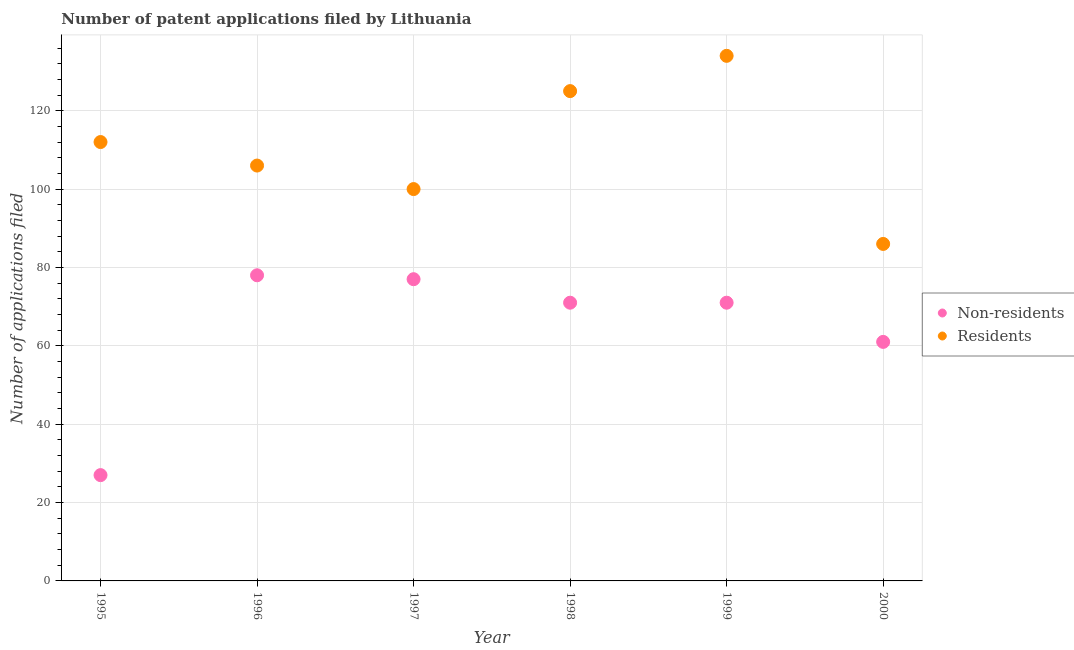How many different coloured dotlines are there?
Provide a succinct answer. 2. Is the number of dotlines equal to the number of legend labels?
Provide a succinct answer. Yes. What is the number of patent applications by residents in 1998?
Keep it short and to the point. 125. Across all years, what is the maximum number of patent applications by residents?
Your answer should be very brief. 134. Across all years, what is the minimum number of patent applications by non residents?
Your answer should be very brief. 27. In which year was the number of patent applications by residents maximum?
Give a very brief answer. 1999. In which year was the number of patent applications by non residents minimum?
Make the answer very short. 1995. What is the total number of patent applications by non residents in the graph?
Make the answer very short. 385. What is the difference between the number of patent applications by non residents in 1999 and that in 2000?
Your response must be concise. 10. What is the difference between the number of patent applications by residents in 2000 and the number of patent applications by non residents in 1998?
Your answer should be compact. 15. What is the average number of patent applications by residents per year?
Provide a short and direct response. 110.5. In the year 1998, what is the difference between the number of patent applications by residents and number of patent applications by non residents?
Ensure brevity in your answer.  54. Is the difference between the number of patent applications by residents in 1996 and 1998 greater than the difference between the number of patent applications by non residents in 1996 and 1998?
Give a very brief answer. No. What is the difference between the highest and the second highest number of patent applications by non residents?
Provide a short and direct response. 1. What is the difference between the highest and the lowest number of patent applications by residents?
Provide a succinct answer. 48. Does the number of patent applications by residents monotonically increase over the years?
Provide a short and direct response. No. Is the number of patent applications by non residents strictly greater than the number of patent applications by residents over the years?
Your answer should be very brief. No. Are the values on the major ticks of Y-axis written in scientific E-notation?
Your response must be concise. No. Where does the legend appear in the graph?
Your response must be concise. Center right. How many legend labels are there?
Ensure brevity in your answer.  2. How are the legend labels stacked?
Offer a terse response. Vertical. What is the title of the graph?
Keep it short and to the point. Number of patent applications filed by Lithuania. What is the label or title of the Y-axis?
Keep it short and to the point. Number of applications filed. What is the Number of applications filed of Residents in 1995?
Your response must be concise. 112. What is the Number of applications filed in Non-residents in 1996?
Ensure brevity in your answer.  78. What is the Number of applications filed in Residents in 1996?
Your answer should be compact. 106. What is the Number of applications filed in Non-residents in 1997?
Make the answer very short. 77. What is the Number of applications filed of Residents in 1998?
Your answer should be very brief. 125. What is the Number of applications filed in Residents in 1999?
Offer a terse response. 134. What is the Number of applications filed in Non-residents in 2000?
Your response must be concise. 61. Across all years, what is the maximum Number of applications filed of Non-residents?
Offer a very short reply. 78. Across all years, what is the maximum Number of applications filed in Residents?
Your response must be concise. 134. What is the total Number of applications filed in Non-residents in the graph?
Your answer should be compact. 385. What is the total Number of applications filed of Residents in the graph?
Provide a short and direct response. 663. What is the difference between the Number of applications filed in Non-residents in 1995 and that in 1996?
Ensure brevity in your answer.  -51. What is the difference between the Number of applications filed in Residents in 1995 and that in 1996?
Make the answer very short. 6. What is the difference between the Number of applications filed of Non-residents in 1995 and that in 1997?
Ensure brevity in your answer.  -50. What is the difference between the Number of applications filed of Non-residents in 1995 and that in 1998?
Your answer should be very brief. -44. What is the difference between the Number of applications filed in Residents in 1995 and that in 1998?
Ensure brevity in your answer.  -13. What is the difference between the Number of applications filed of Non-residents in 1995 and that in 1999?
Provide a succinct answer. -44. What is the difference between the Number of applications filed of Residents in 1995 and that in 1999?
Keep it short and to the point. -22. What is the difference between the Number of applications filed of Non-residents in 1995 and that in 2000?
Give a very brief answer. -34. What is the difference between the Number of applications filed of Non-residents in 1996 and that in 1997?
Ensure brevity in your answer.  1. What is the difference between the Number of applications filed of Non-residents in 1996 and that in 1998?
Provide a short and direct response. 7. What is the difference between the Number of applications filed of Residents in 1996 and that in 1998?
Keep it short and to the point. -19. What is the difference between the Number of applications filed of Residents in 1996 and that in 1999?
Provide a short and direct response. -28. What is the difference between the Number of applications filed of Residents in 1996 and that in 2000?
Make the answer very short. 20. What is the difference between the Number of applications filed in Non-residents in 1997 and that in 1998?
Provide a short and direct response. 6. What is the difference between the Number of applications filed in Residents in 1997 and that in 1998?
Ensure brevity in your answer.  -25. What is the difference between the Number of applications filed of Residents in 1997 and that in 1999?
Your response must be concise. -34. What is the difference between the Number of applications filed in Residents in 1997 and that in 2000?
Your answer should be compact. 14. What is the difference between the Number of applications filed in Non-residents in 1998 and that in 2000?
Provide a short and direct response. 10. What is the difference between the Number of applications filed of Non-residents in 1999 and that in 2000?
Keep it short and to the point. 10. What is the difference between the Number of applications filed of Non-residents in 1995 and the Number of applications filed of Residents in 1996?
Provide a succinct answer. -79. What is the difference between the Number of applications filed of Non-residents in 1995 and the Number of applications filed of Residents in 1997?
Ensure brevity in your answer.  -73. What is the difference between the Number of applications filed in Non-residents in 1995 and the Number of applications filed in Residents in 1998?
Give a very brief answer. -98. What is the difference between the Number of applications filed in Non-residents in 1995 and the Number of applications filed in Residents in 1999?
Provide a succinct answer. -107. What is the difference between the Number of applications filed of Non-residents in 1995 and the Number of applications filed of Residents in 2000?
Your answer should be compact. -59. What is the difference between the Number of applications filed in Non-residents in 1996 and the Number of applications filed in Residents in 1998?
Offer a very short reply. -47. What is the difference between the Number of applications filed of Non-residents in 1996 and the Number of applications filed of Residents in 1999?
Your response must be concise. -56. What is the difference between the Number of applications filed in Non-residents in 1996 and the Number of applications filed in Residents in 2000?
Ensure brevity in your answer.  -8. What is the difference between the Number of applications filed in Non-residents in 1997 and the Number of applications filed in Residents in 1998?
Offer a terse response. -48. What is the difference between the Number of applications filed of Non-residents in 1997 and the Number of applications filed of Residents in 1999?
Provide a succinct answer. -57. What is the difference between the Number of applications filed in Non-residents in 1998 and the Number of applications filed in Residents in 1999?
Provide a succinct answer. -63. What is the average Number of applications filed of Non-residents per year?
Your answer should be compact. 64.17. What is the average Number of applications filed of Residents per year?
Keep it short and to the point. 110.5. In the year 1995, what is the difference between the Number of applications filed in Non-residents and Number of applications filed in Residents?
Offer a very short reply. -85. In the year 1996, what is the difference between the Number of applications filed of Non-residents and Number of applications filed of Residents?
Provide a succinct answer. -28. In the year 1998, what is the difference between the Number of applications filed in Non-residents and Number of applications filed in Residents?
Offer a very short reply. -54. In the year 1999, what is the difference between the Number of applications filed in Non-residents and Number of applications filed in Residents?
Ensure brevity in your answer.  -63. What is the ratio of the Number of applications filed in Non-residents in 1995 to that in 1996?
Make the answer very short. 0.35. What is the ratio of the Number of applications filed of Residents in 1995 to that in 1996?
Provide a short and direct response. 1.06. What is the ratio of the Number of applications filed in Non-residents in 1995 to that in 1997?
Provide a short and direct response. 0.35. What is the ratio of the Number of applications filed in Residents in 1995 to that in 1997?
Your response must be concise. 1.12. What is the ratio of the Number of applications filed of Non-residents in 1995 to that in 1998?
Provide a succinct answer. 0.38. What is the ratio of the Number of applications filed of Residents in 1995 to that in 1998?
Provide a short and direct response. 0.9. What is the ratio of the Number of applications filed of Non-residents in 1995 to that in 1999?
Give a very brief answer. 0.38. What is the ratio of the Number of applications filed in Residents in 1995 to that in 1999?
Provide a succinct answer. 0.84. What is the ratio of the Number of applications filed of Non-residents in 1995 to that in 2000?
Your response must be concise. 0.44. What is the ratio of the Number of applications filed in Residents in 1995 to that in 2000?
Keep it short and to the point. 1.3. What is the ratio of the Number of applications filed in Non-residents in 1996 to that in 1997?
Your answer should be compact. 1.01. What is the ratio of the Number of applications filed in Residents in 1996 to that in 1997?
Provide a short and direct response. 1.06. What is the ratio of the Number of applications filed of Non-residents in 1996 to that in 1998?
Keep it short and to the point. 1.1. What is the ratio of the Number of applications filed of Residents in 1996 to that in 1998?
Keep it short and to the point. 0.85. What is the ratio of the Number of applications filed in Non-residents in 1996 to that in 1999?
Your answer should be very brief. 1.1. What is the ratio of the Number of applications filed in Residents in 1996 to that in 1999?
Make the answer very short. 0.79. What is the ratio of the Number of applications filed of Non-residents in 1996 to that in 2000?
Offer a terse response. 1.28. What is the ratio of the Number of applications filed of Residents in 1996 to that in 2000?
Your answer should be compact. 1.23. What is the ratio of the Number of applications filed of Non-residents in 1997 to that in 1998?
Your answer should be very brief. 1.08. What is the ratio of the Number of applications filed of Residents in 1997 to that in 1998?
Your answer should be compact. 0.8. What is the ratio of the Number of applications filed in Non-residents in 1997 to that in 1999?
Keep it short and to the point. 1.08. What is the ratio of the Number of applications filed of Residents in 1997 to that in 1999?
Make the answer very short. 0.75. What is the ratio of the Number of applications filed of Non-residents in 1997 to that in 2000?
Keep it short and to the point. 1.26. What is the ratio of the Number of applications filed of Residents in 1997 to that in 2000?
Your answer should be compact. 1.16. What is the ratio of the Number of applications filed of Residents in 1998 to that in 1999?
Offer a very short reply. 0.93. What is the ratio of the Number of applications filed in Non-residents in 1998 to that in 2000?
Provide a succinct answer. 1.16. What is the ratio of the Number of applications filed in Residents in 1998 to that in 2000?
Offer a terse response. 1.45. What is the ratio of the Number of applications filed in Non-residents in 1999 to that in 2000?
Your answer should be very brief. 1.16. What is the ratio of the Number of applications filed in Residents in 1999 to that in 2000?
Your answer should be compact. 1.56. What is the difference between the highest and the second highest Number of applications filed of Non-residents?
Your response must be concise. 1. 